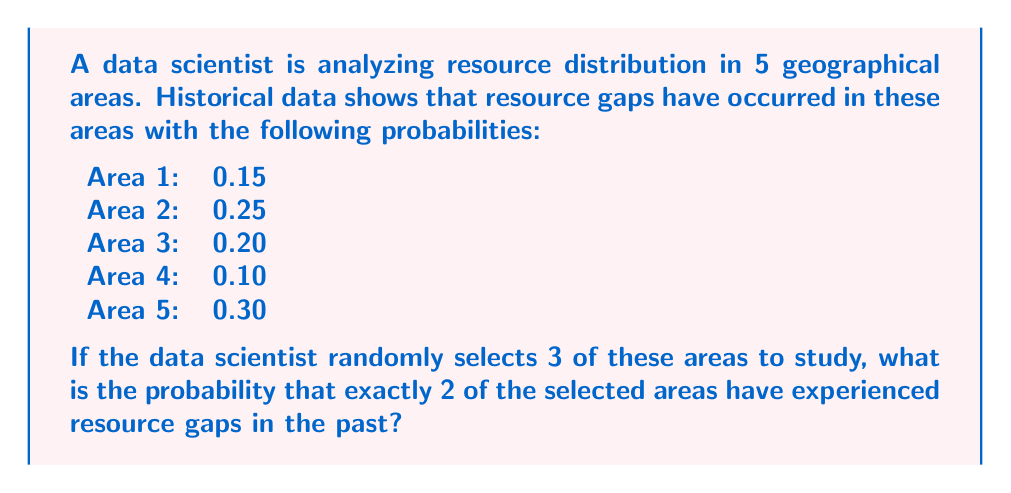Can you solve this math problem? To solve this problem, we can use the concept of binomial probability. We need to calculate the probability of exactly 2 successes (areas with resource gaps) in 3 trials (selected areas).

Let's approach this step-by-step:

1) First, we need to calculate the average probability of a resource gap occurring in any area:

   $p = \frac{0.15 + 0.25 + 0.20 + 0.10 + 0.30}{5} = 0.20$

2) Now, we can use the binomial probability formula:

   $P(X = k) = \binom{n}{k} p^k (1-p)^{n-k}$

   Where:
   $n$ = number of trials (3 in this case)
   $k$ = number of successes (2 in this case)
   $p$ = probability of success on each trial (0.20 as calculated)

3) Let's substitute these values:

   $P(X = 2) = \binom{3}{2} (0.20)^2 (1-0.20)^{3-2}$

4) Calculate the binomial coefficient:

   $\binom{3}{2} = \frac{3!}{2!(3-2)!} = \frac{3 \cdot 2 \cdot 1}{(2 \cdot 1)(1)} = 3$

5) Now our equation looks like:

   $P(X = 2) = 3 \cdot (0.20)^2 \cdot (0.80)^1$

6) Solve:

   $P(X = 2) = 3 \cdot 0.04 \cdot 0.80 = 0.096$

Therefore, the probability of exactly 2 out of 3 randomly selected areas having experienced resource gaps is 0.096 or 9.6%.
Answer: 0.096 or 9.6% 